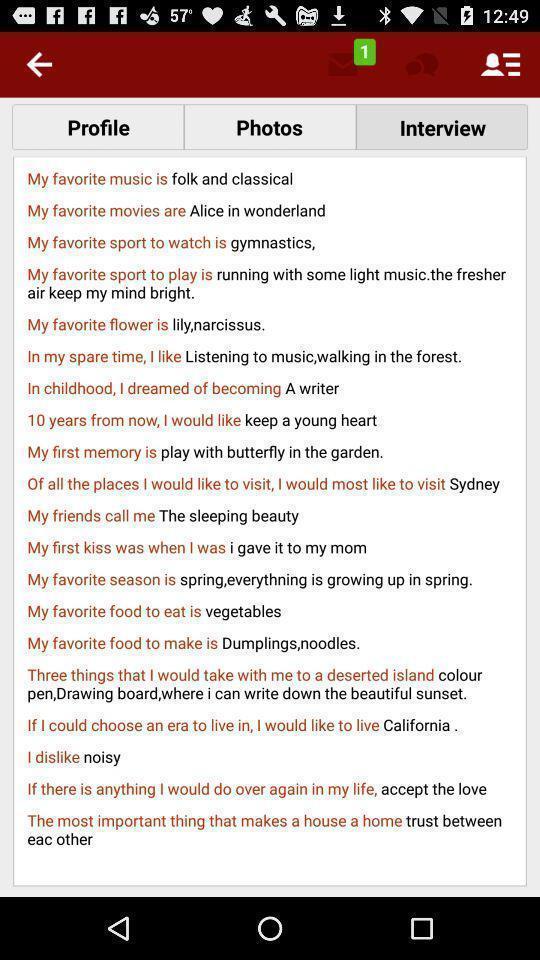Provide a detailed account of this screenshot. Screen displaying interview question and answers. 